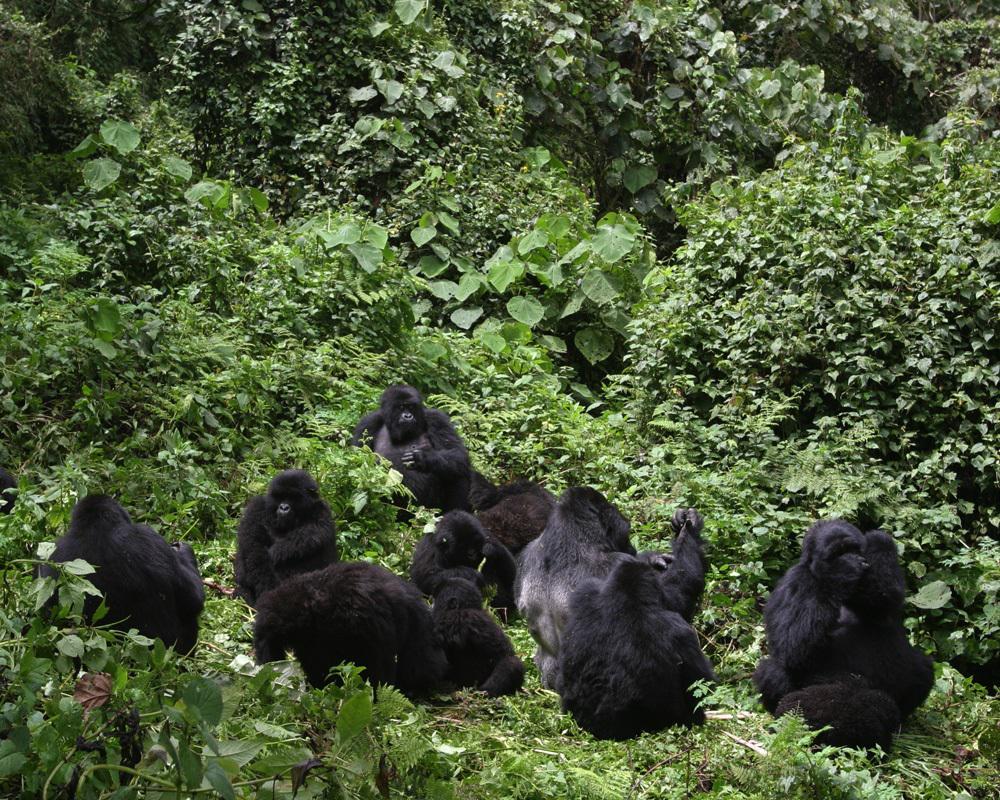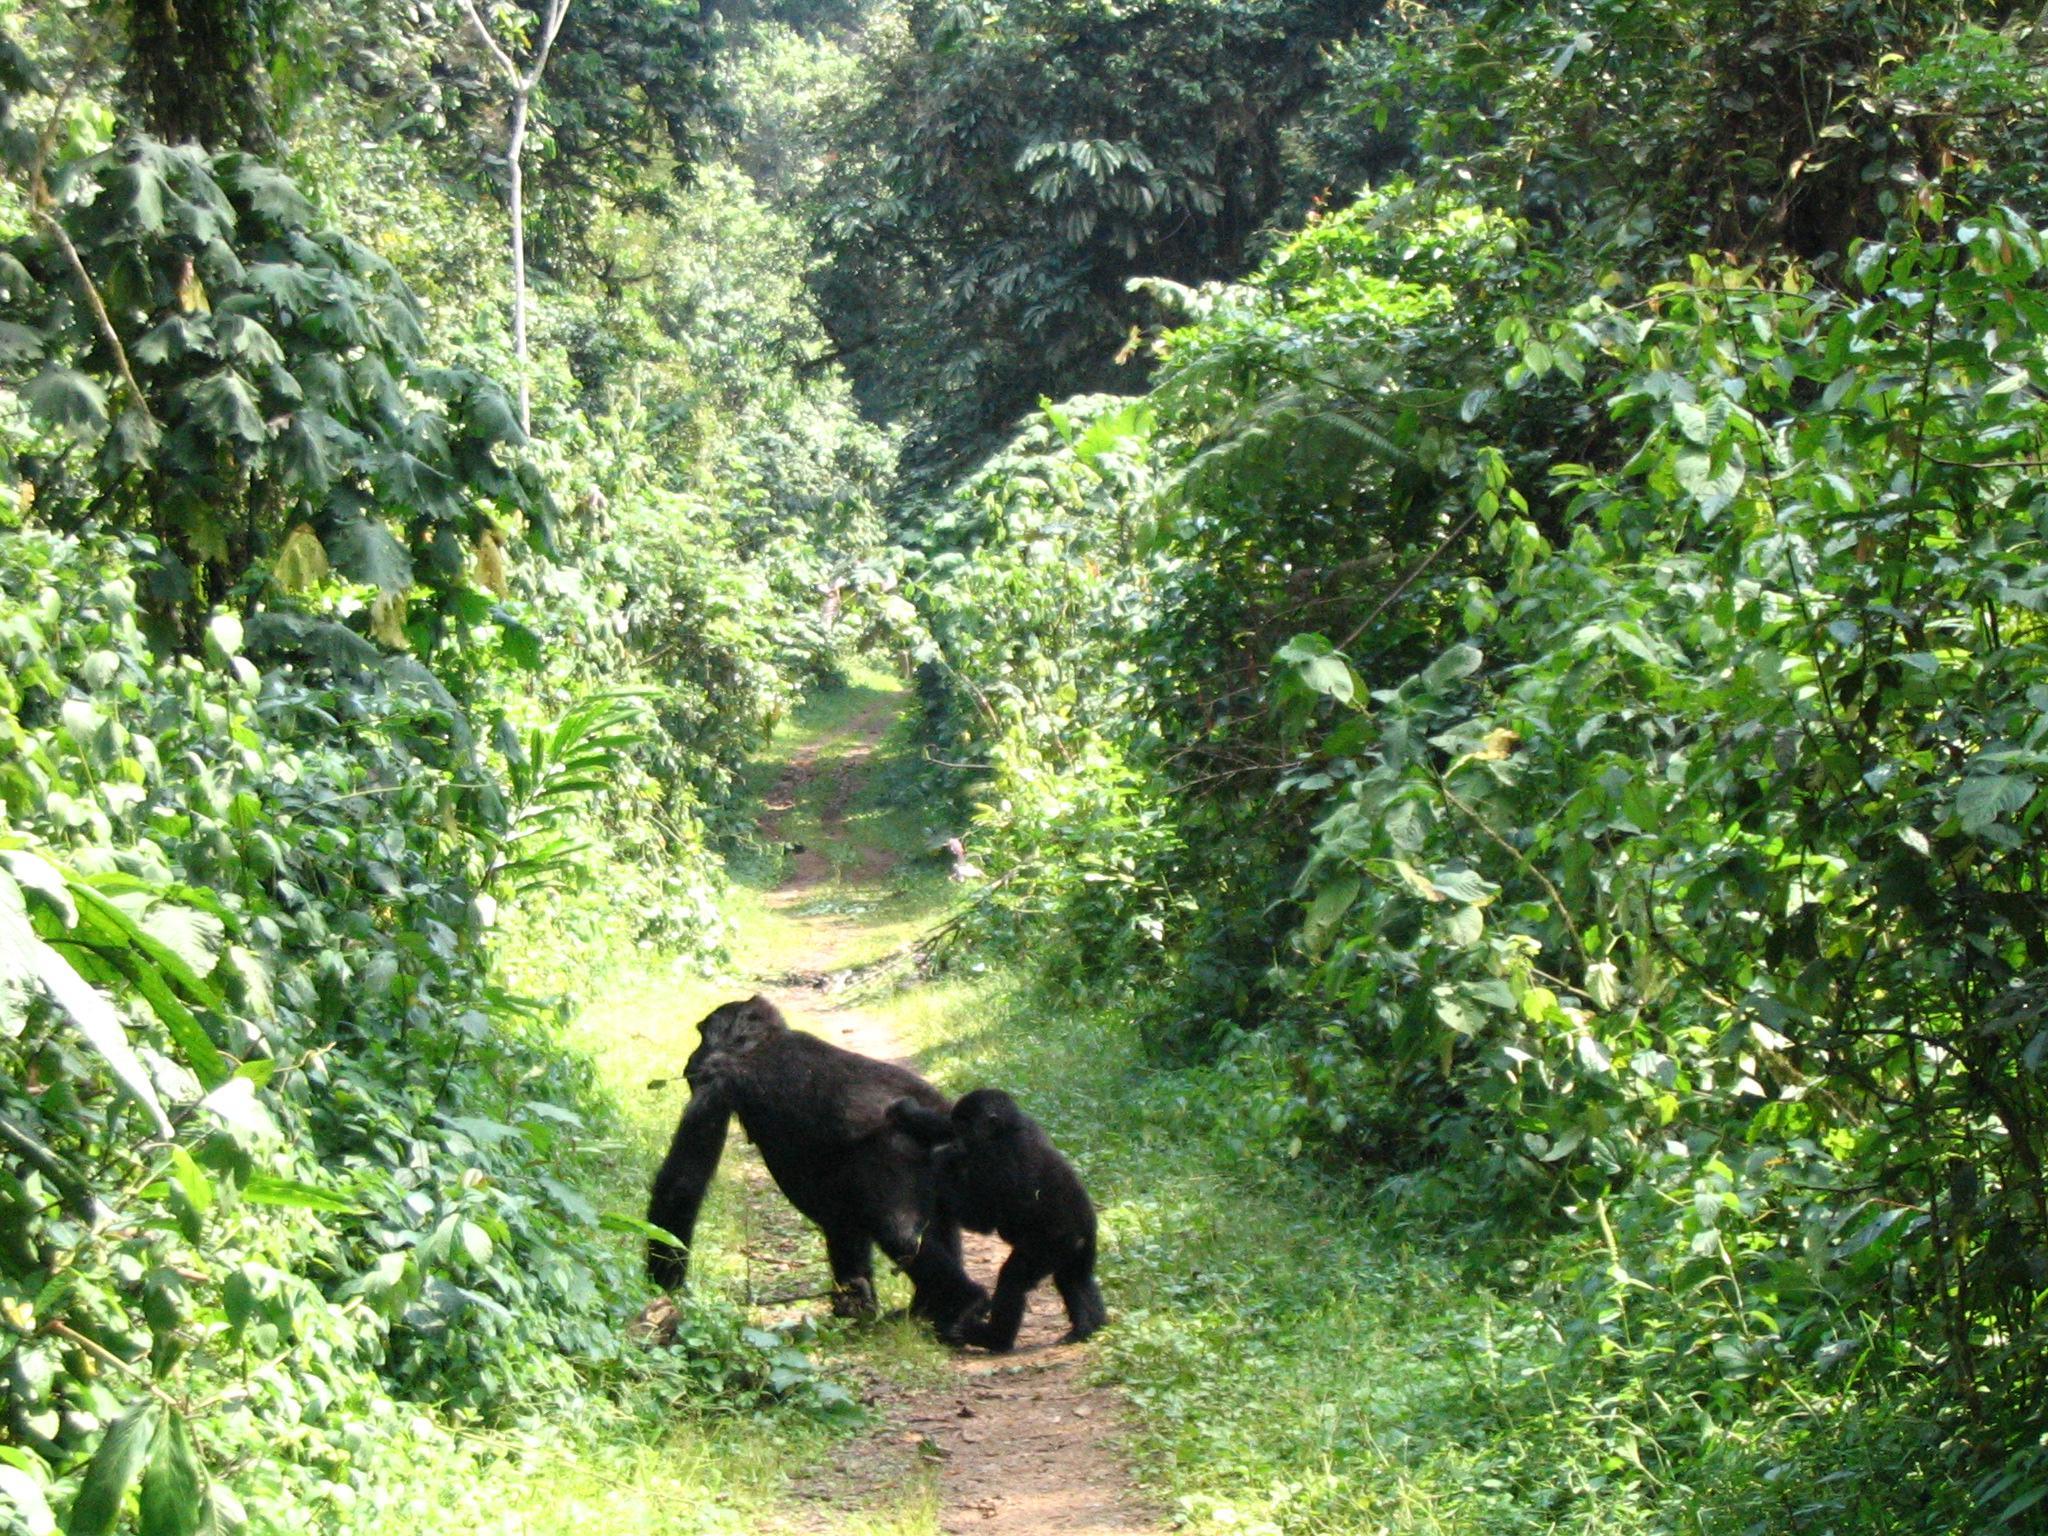The first image is the image on the left, the second image is the image on the right. Examine the images to the left and right. Is the description "There are two adult gurallies and two baby gurilles.  gorialles gore" accurate? Answer yes or no. No. The first image is the image on the left, the second image is the image on the right. Assess this claim about the two images: "In one image, one gorilla is walking leftward behind another and reaching an arm out to touch it.". Correct or not? Answer yes or no. Yes. 